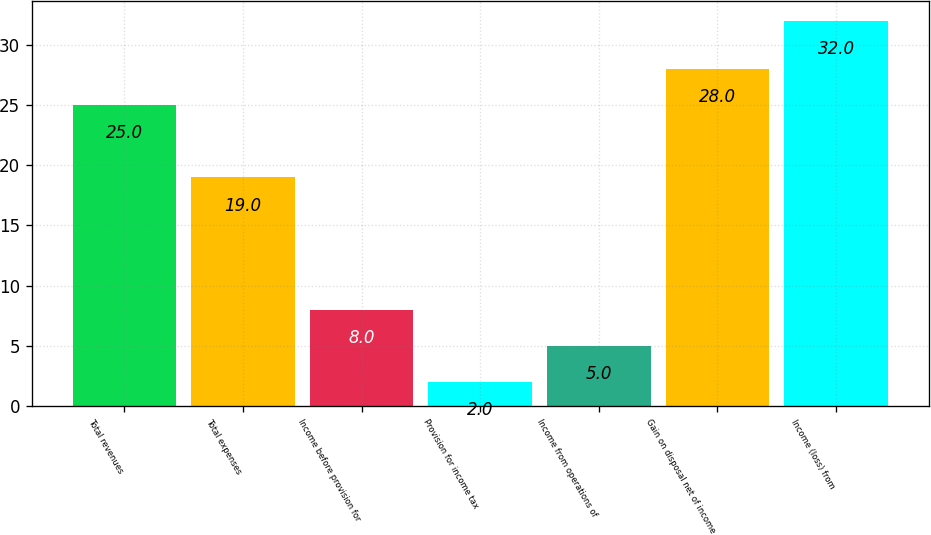Convert chart. <chart><loc_0><loc_0><loc_500><loc_500><bar_chart><fcel>Total revenues<fcel>Total expenses<fcel>Income before provision for<fcel>Provision for income tax<fcel>Income from operations of<fcel>Gain on disposal net of income<fcel>Income (loss) from<nl><fcel>25<fcel>19<fcel>8<fcel>2<fcel>5<fcel>28<fcel>32<nl></chart> 